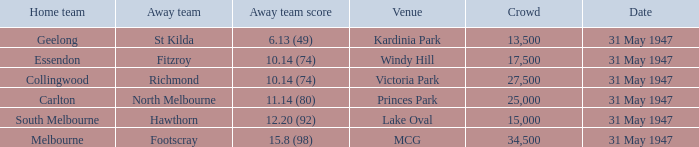What is the host team's score at mcg? 17.3 (105). 